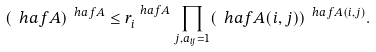<formula> <loc_0><loc_0><loc_500><loc_500>( \ h a f A ) ^ { \ h a f A } \leq r _ { i } ^ { \ h a f A } \prod _ { j , a _ { i j } = 1 } ( \ h a f A ( i , j ) ) ^ { \ h a f A ( i , j ) } .</formula> 